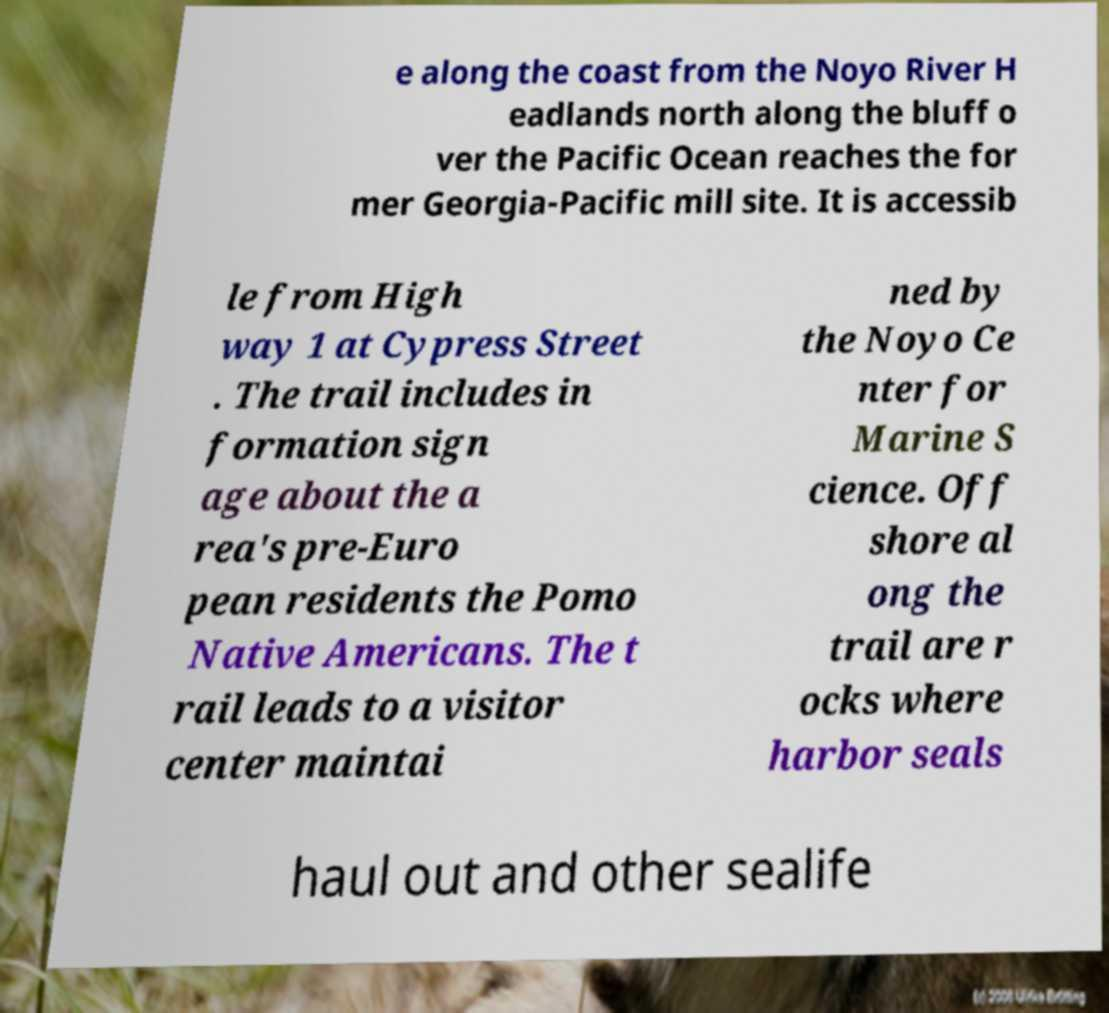Could you assist in decoding the text presented in this image and type it out clearly? e along the coast from the Noyo River H eadlands north along the bluff o ver the Pacific Ocean reaches the for mer Georgia-Pacific mill site. It is accessib le from High way 1 at Cypress Street . The trail includes in formation sign age about the a rea's pre-Euro pean residents the Pomo Native Americans. The t rail leads to a visitor center maintai ned by the Noyo Ce nter for Marine S cience. Off shore al ong the trail are r ocks where harbor seals haul out and other sealife 